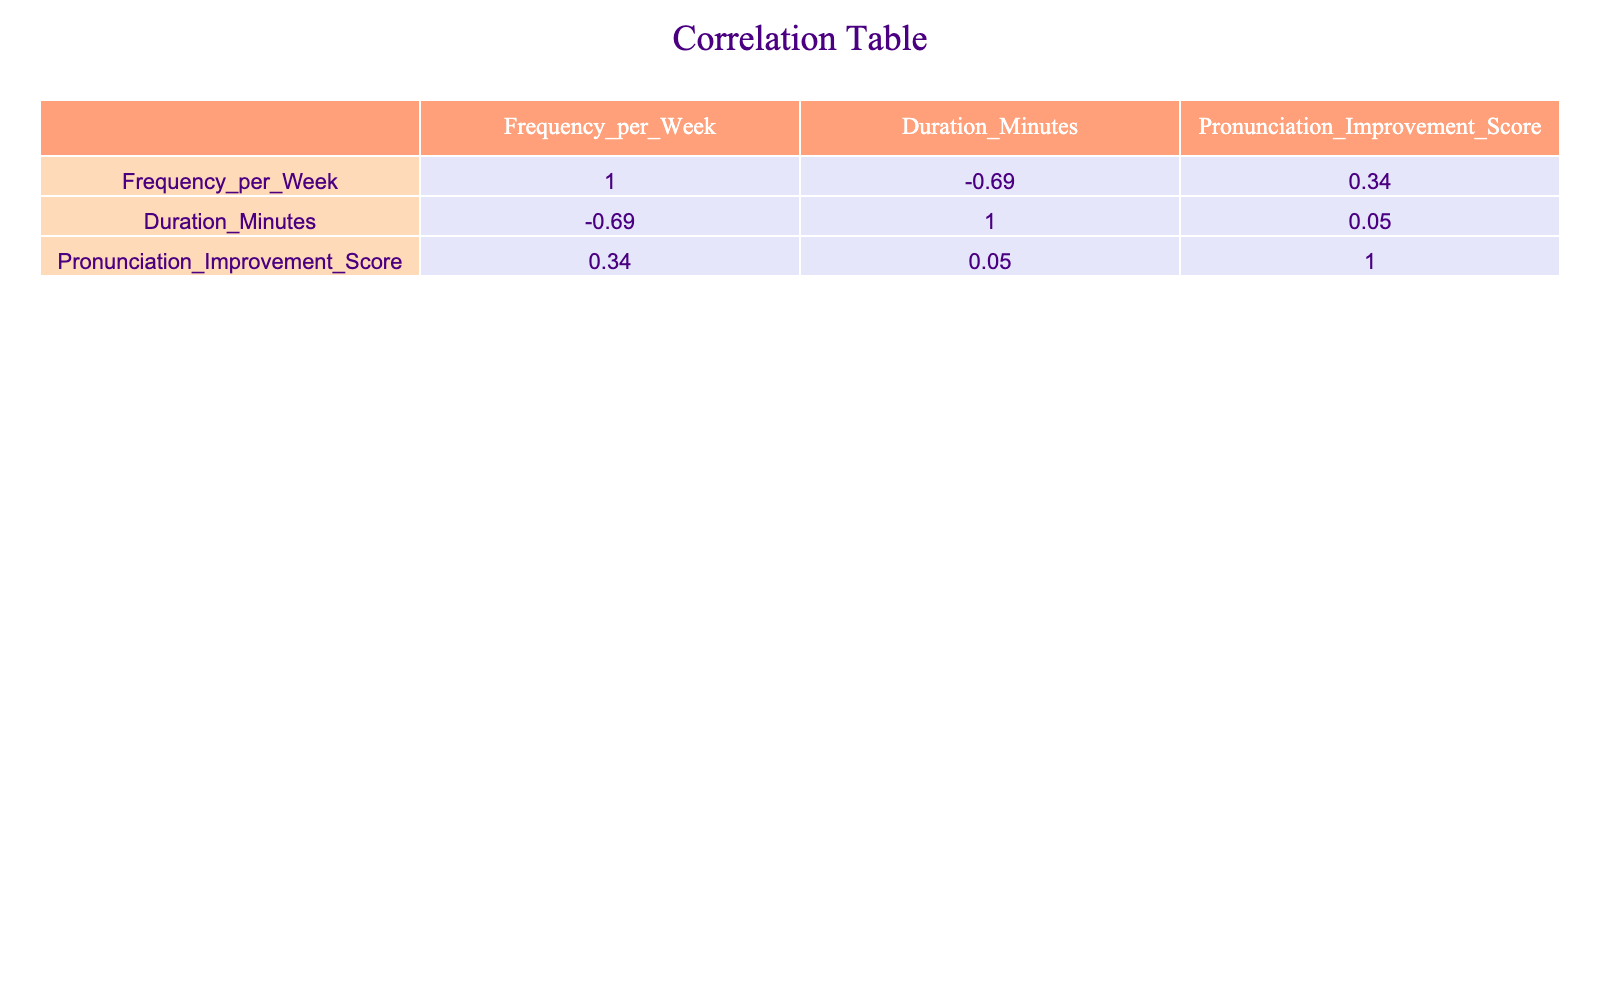What activity has the highest pronunciation improvement score? By looking at the pronunciation improvement scores for each activity listed in the table, "Speech Therapy Sessions" has the highest score of 9.
Answer: 9 What is the frequency per week of practicing monologues? The frequency per week for "Practicing Monologues" is provided directly in the table, which shows a frequency of 1.
Answer: 1 Is the pronunciation improvement score for interactive games greater than or equal to 6? The pronunciation improvement score for "Interactive Games" is 6, which means it meets the condition of being greater than or equal to 6.
Answer: Yes What is the average duration of activities that have a pronunciation improvement score of 8 or higher? The activities with a score of 8 or higher are "Reading Aloud" (30 minutes), "Record and Playback" (20 minutes), and "Speech Therapy Sessions" (60 minutes). Summing these durations gives 30 + 20 + 60 = 110 minutes. There are 3 activities, so the average duration is 110/3 = approximately 36.67 minutes.
Answer: 36.67 What is the difference between the frequency of reading aloud and phonetic exercises? The frequency of "Reading Aloud" is 5, and the frequency of "Phonetic Exercises" is 3. The difference is calculated by subtracting the frequency of phonetic exercises from the frequency of reading aloud: 5 - 3 = 2.
Answer: 2 How many activities have a frequency of 2 or less? The activities with a frequency of 2 or less are "Speech Therapy Sessions" (2), "Storytelling With Friends" (2), and "Practicing Monologues" (1). Counting these, there are a total of 3 activities.
Answer: 3 Are there any activities that have a frequency and improvement score both equal to 3? There is no activity listed with a frequency of 3 that also has a pronunciation improvement score of 3. The closest frequency is found in "Tongue Twisters" and "Phonetic Exercises", but their scores are 7 and 9, respectively.
Answer: No What is the total pronunciation improvement score for activities that are practiced 3 or more times a week? The activities practiced 3 or more times a week are "Reading Aloud" (8), "Tongue Twisters" (7), "Record and Playback" (8), and "Phonetic Exercises" (9). Summing their scores gives 8 + 7 + 8 + 9 = 32.
Answer: 32 